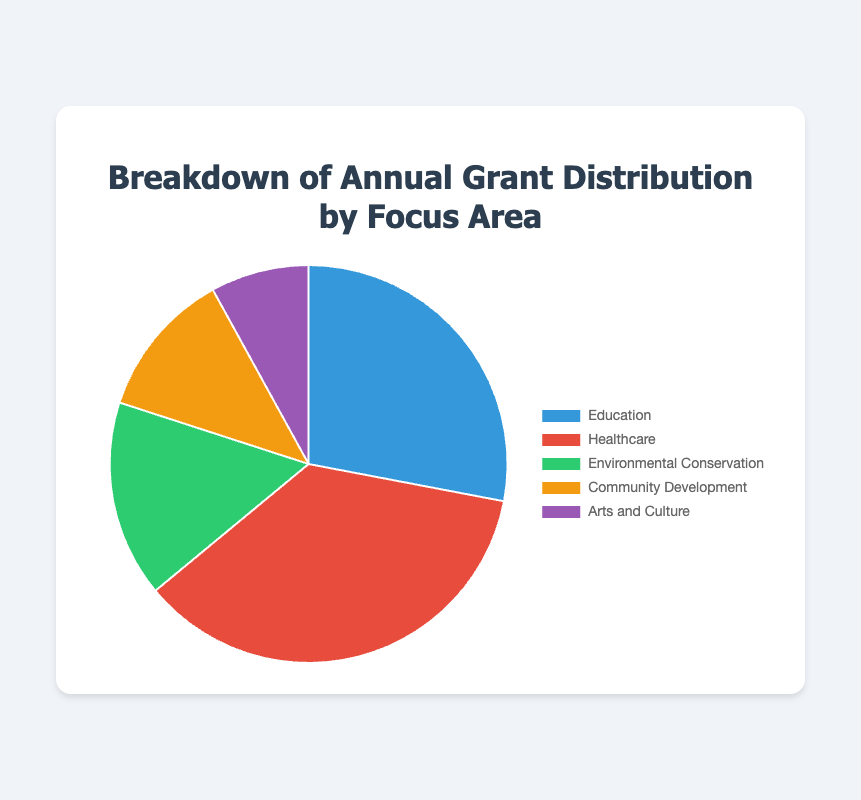What is the total amount of grants distributed? To find the total amount of grants distributed, sum up the amounts for all focus areas: $350,000 (Education) + $450,000 (Healthcare) + $200,000 (Environmental Conservation) + $150,000 (Community Development) + $100,000 (Arts and Culture). This equals $1,250,000.
Answer: $1,250,000 Which focus area received the largest grant? By comparing the amounts, Healthcare received the largest grant with $450,000.
Answer: Healthcare What percentage of the total grants is allocated to Healthcare? First, find the total amount of grants distributed, which is $1,250,000. Then, divide the amount for Healthcare ($450,000) by the total and multiply by 100 to get: ($450,000 / $1,250,000) * 100 ≈ 36%.
Answer: 36% Which section of the pie chart is green? The green section of the pie chart represents Environmental Conservation, which was allocated $200,000.
Answer: Environmental Conservation How much more funding did Education receive compared to Community Development? Education received $350,000 and Community Development received $150,000. The difference is $350,000 - $150,000 = $200,000.
Answer: $200,000 What is the combined amount allocated to Community Development and Arts and Culture? Community Development received $150,000 and Arts and Culture received $100,000. The combined amount is $150,000 + $100,000 = $250,000.
Answer: $250,000 What is the average amount of grants allocated per focus area? To find the average, sum the total grants distributed ($1,250,000) and divide by the number of focus areas (5). This gives $1,250,000 / 5 = $250,000.
Answer: $250,000 Which focus area received the smallest grant? By comparing the amounts, Arts and Culture received the smallest grant with $100,000.
Answer: Arts and Culture How does the funding for Environmental Conservation compare to Healthcare in terms of percentage? First, find the percentage of the total grants for each: Environmental Conservation ($200,000) is ($200,000 / $1,250,000) * 100 ≈ 16%. Healthcare ($450,000) is ($450,000 / $1,250,000) * 100 ≈ 36%.
Answer: Environmental Conservation: 16%, Healthcare: 36% What is the difference in funding between the focus area receiving the most and the least? The largest grant was $450,000 (Healthcare) and the smallest was $100,000 (Arts and Culture). The difference is $450,000 - $100,000 = $350,000.
Answer: $350,000 